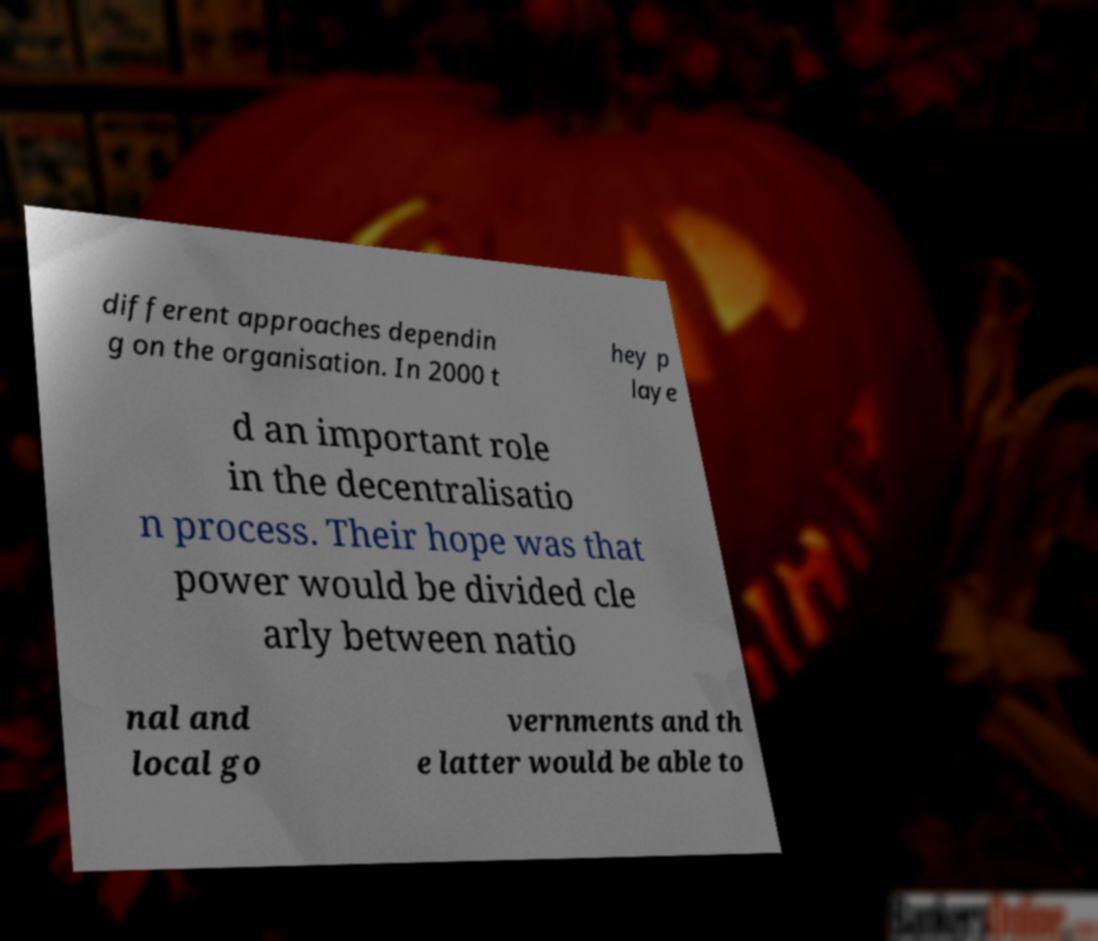I need the written content from this picture converted into text. Can you do that? different approaches dependin g on the organisation. In 2000 t hey p laye d an important role in the decentralisatio n process. Their hope was that power would be divided cle arly between natio nal and local go vernments and th e latter would be able to 